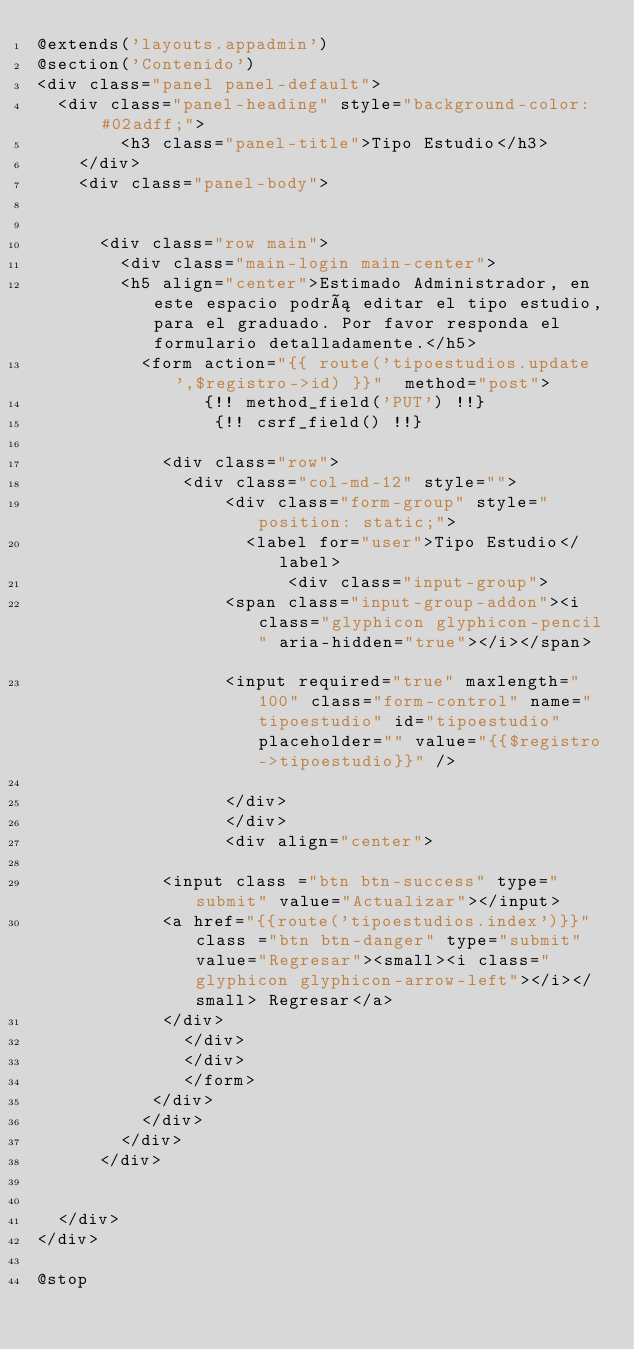Convert code to text. <code><loc_0><loc_0><loc_500><loc_500><_PHP_>@extends('layouts.appadmin')
@section('Contenido')
<div class="panel panel-default">
	<div class="panel-heading" style="background-color:  #02adff;">
        <h3 class="panel-title">Tipo Estudio</h3>
    </div>
    <div class="panel-body">
    	
	 	
			<div class="row main">
				<div class="main-login main-center">
				<h5 align="center">Estimado Administrador, en este espacio podrá editar el tipo estudio,para el graduado. Por favor responda el formulario detalladamente.</h5>
					<form action="{{ route('tipoestudios.update',$registro->id) }}"  method="post"> 
           			{!! method_field('PUT') !!}
           			 {!! csrf_field() !!} 
						
						<div class="row">
					    <div class="col-md-12" style="">
					        <div class="form-group" style="position: static;">
					        	<label for="user">Tipo Estudio</label> 
					            	<div class="input-group">
									<span class="input-group-addon"><i class="glyphicon glyphicon-pencil" aria-hidden="true"></i></span>									
									<input required="true" maxlength="100" class="form-control" name="tipoestudio" id="tipoestudio"  placeholder="" value="{{$registro->tipoestudio}}" /> 
									
									</div>
					        </div>
					        <div align="center">
							
						<input class ="btn btn-success" type="submit" value="Actualizar"></input>
						<a href="{{route('tipoestudios.index')}}" class ="btn btn-danger" type="submit" value="Regresar"><small><i class="glyphicon glyphicon-arrow-left"></i></small> Regresar</a>
						</div>
					    </div>
					    </div>
					    </form>
					 </div>
					</div>
				</div>
			</div>
		

	</div>
</div>

@stop</code> 